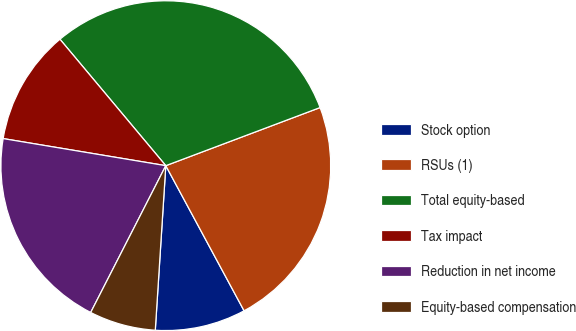Convert chart. <chart><loc_0><loc_0><loc_500><loc_500><pie_chart><fcel>Stock option<fcel>RSUs (1)<fcel>Total equity-based<fcel>Tax impact<fcel>Reduction in net income<fcel>Equity-based compensation<nl><fcel>8.89%<fcel>22.86%<fcel>30.36%<fcel>11.28%<fcel>20.1%<fcel>6.51%<nl></chart> 